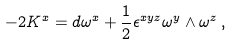Convert formula to latex. <formula><loc_0><loc_0><loc_500><loc_500>- 2 K ^ { x } = d \omega ^ { x } + \frac { 1 } { 2 } \epsilon ^ { x y z } \omega ^ { y } \wedge \omega ^ { z } \, ,</formula> 